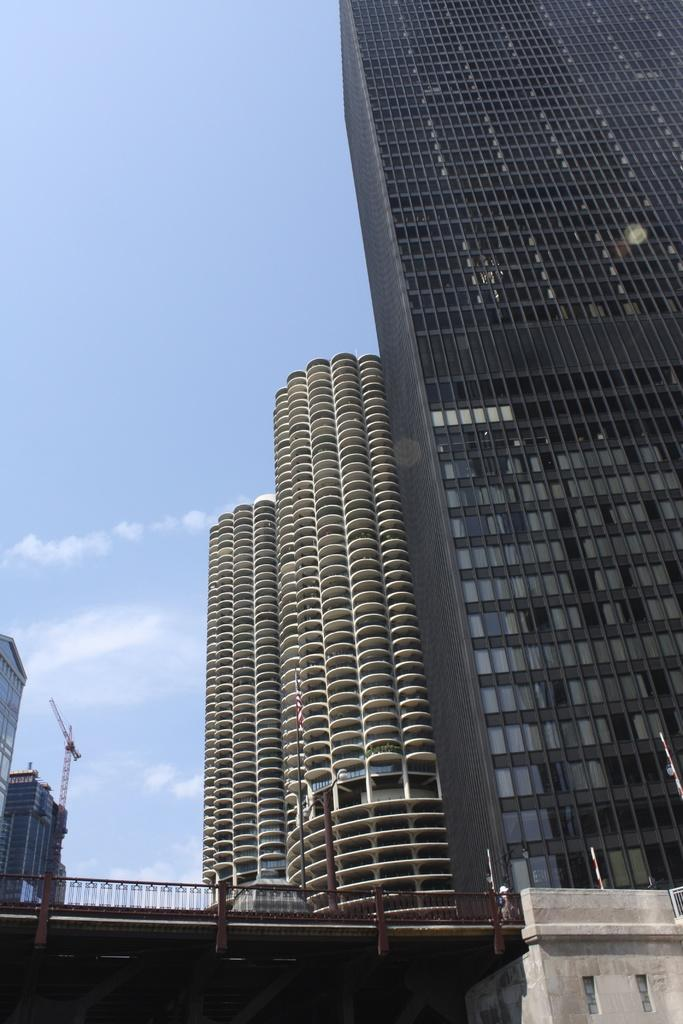What type of structures can be seen in the image? There are buildings in the image. What type of transportation infrastructure is present in the image? There is a bridge in the image. What is visible at the top of the image? The sky is visible at the top of the image. What type of jewel can be seen on the bridge in the image? There is no jewel present on the bridge in the image. What type of adjustment can be seen on the buildings in the image? There is no adjustment visible on the buildings in the image. 